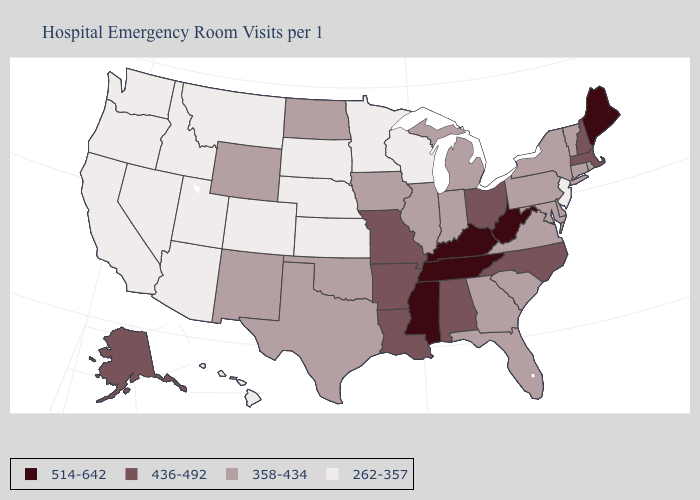Which states have the lowest value in the MidWest?
Answer briefly. Kansas, Minnesota, Nebraska, South Dakota, Wisconsin. Does the first symbol in the legend represent the smallest category?
Concise answer only. No. What is the value of Hawaii?
Keep it brief. 262-357. Does New Jersey have a lower value than Colorado?
Short answer required. No. Does Maine have the highest value in the Northeast?
Be succinct. Yes. What is the value of New Jersey?
Write a very short answer. 262-357. What is the value of Virginia?
Write a very short answer. 358-434. What is the value of Rhode Island?
Quick response, please. 358-434. Among the states that border New Hampshire , which have the highest value?
Give a very brief answer. Maine. What is the value of Connecticut?
Quick response, please. 358-434. Does West Virginia have the highest value in the USA?
Concise answer only. Yes. What is the highest value in states that border Nebraska?
Write a very short answer. 436-492. Is the legend a continuous bar?
Be succinct. No. Does Kentucky have the highest value in the South?
Short answer required. Yes. What is the value of New York?
Write a very short answer. 358-434. 